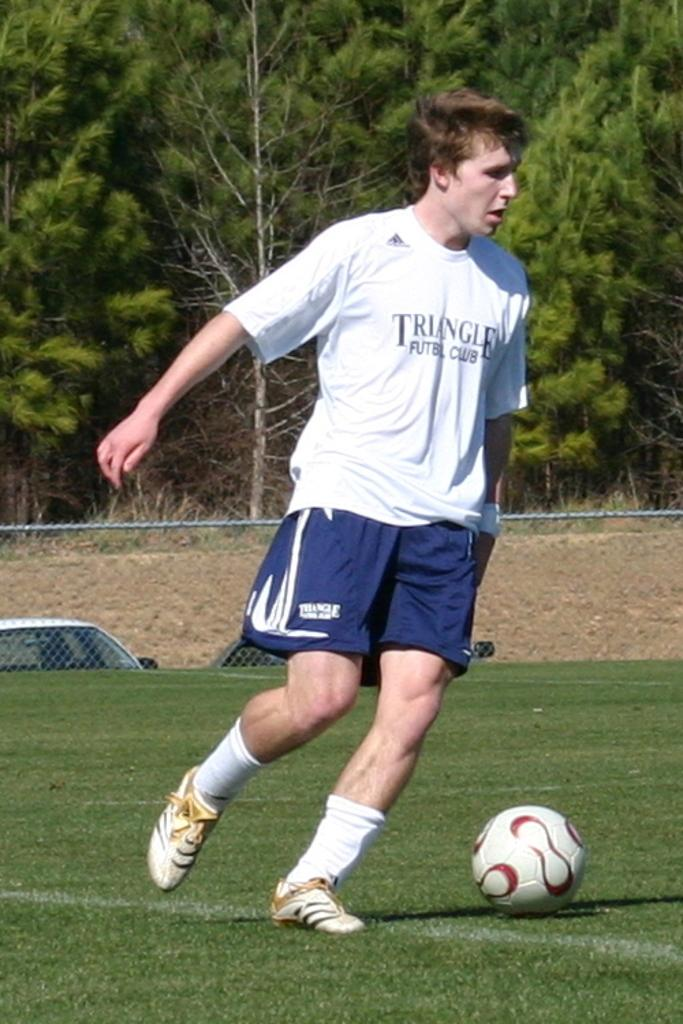<image>
Render a clear and concise summary of the photo. A man wearing a shirt that says Triangle on the front next to a soccer ball. 